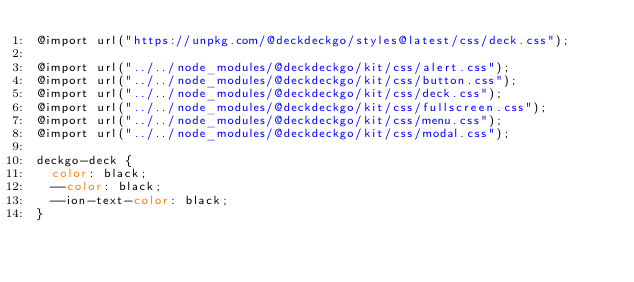<code> <loc_0><loc_0><loc_500><loc_500><_CSS_>@import url("https://unpkg.com/@deckdeckgo/styles@latest/css/deck.css");

@import url("../../node_modules/@deckdeckgo/kit/css/alert.css");
@import url("../../node_modules/@deckdeckgo/kit/css/button.css");
@import url("../../node_modules/@deckdeckgo/kit/css/deck.css");
@import url("../../node_modules/@deckdeckgo/kit/css/fullscreen.css");
@import url("../../node_modules/@deckdeckgo/kit/css/menu.css");
@import url("../../node_modules/@deckdeckgo/kit/css/modal.css");

deckgo-deck {
  color: black;
  --color: black;
  --ion-text-color: black;
}
</code> 